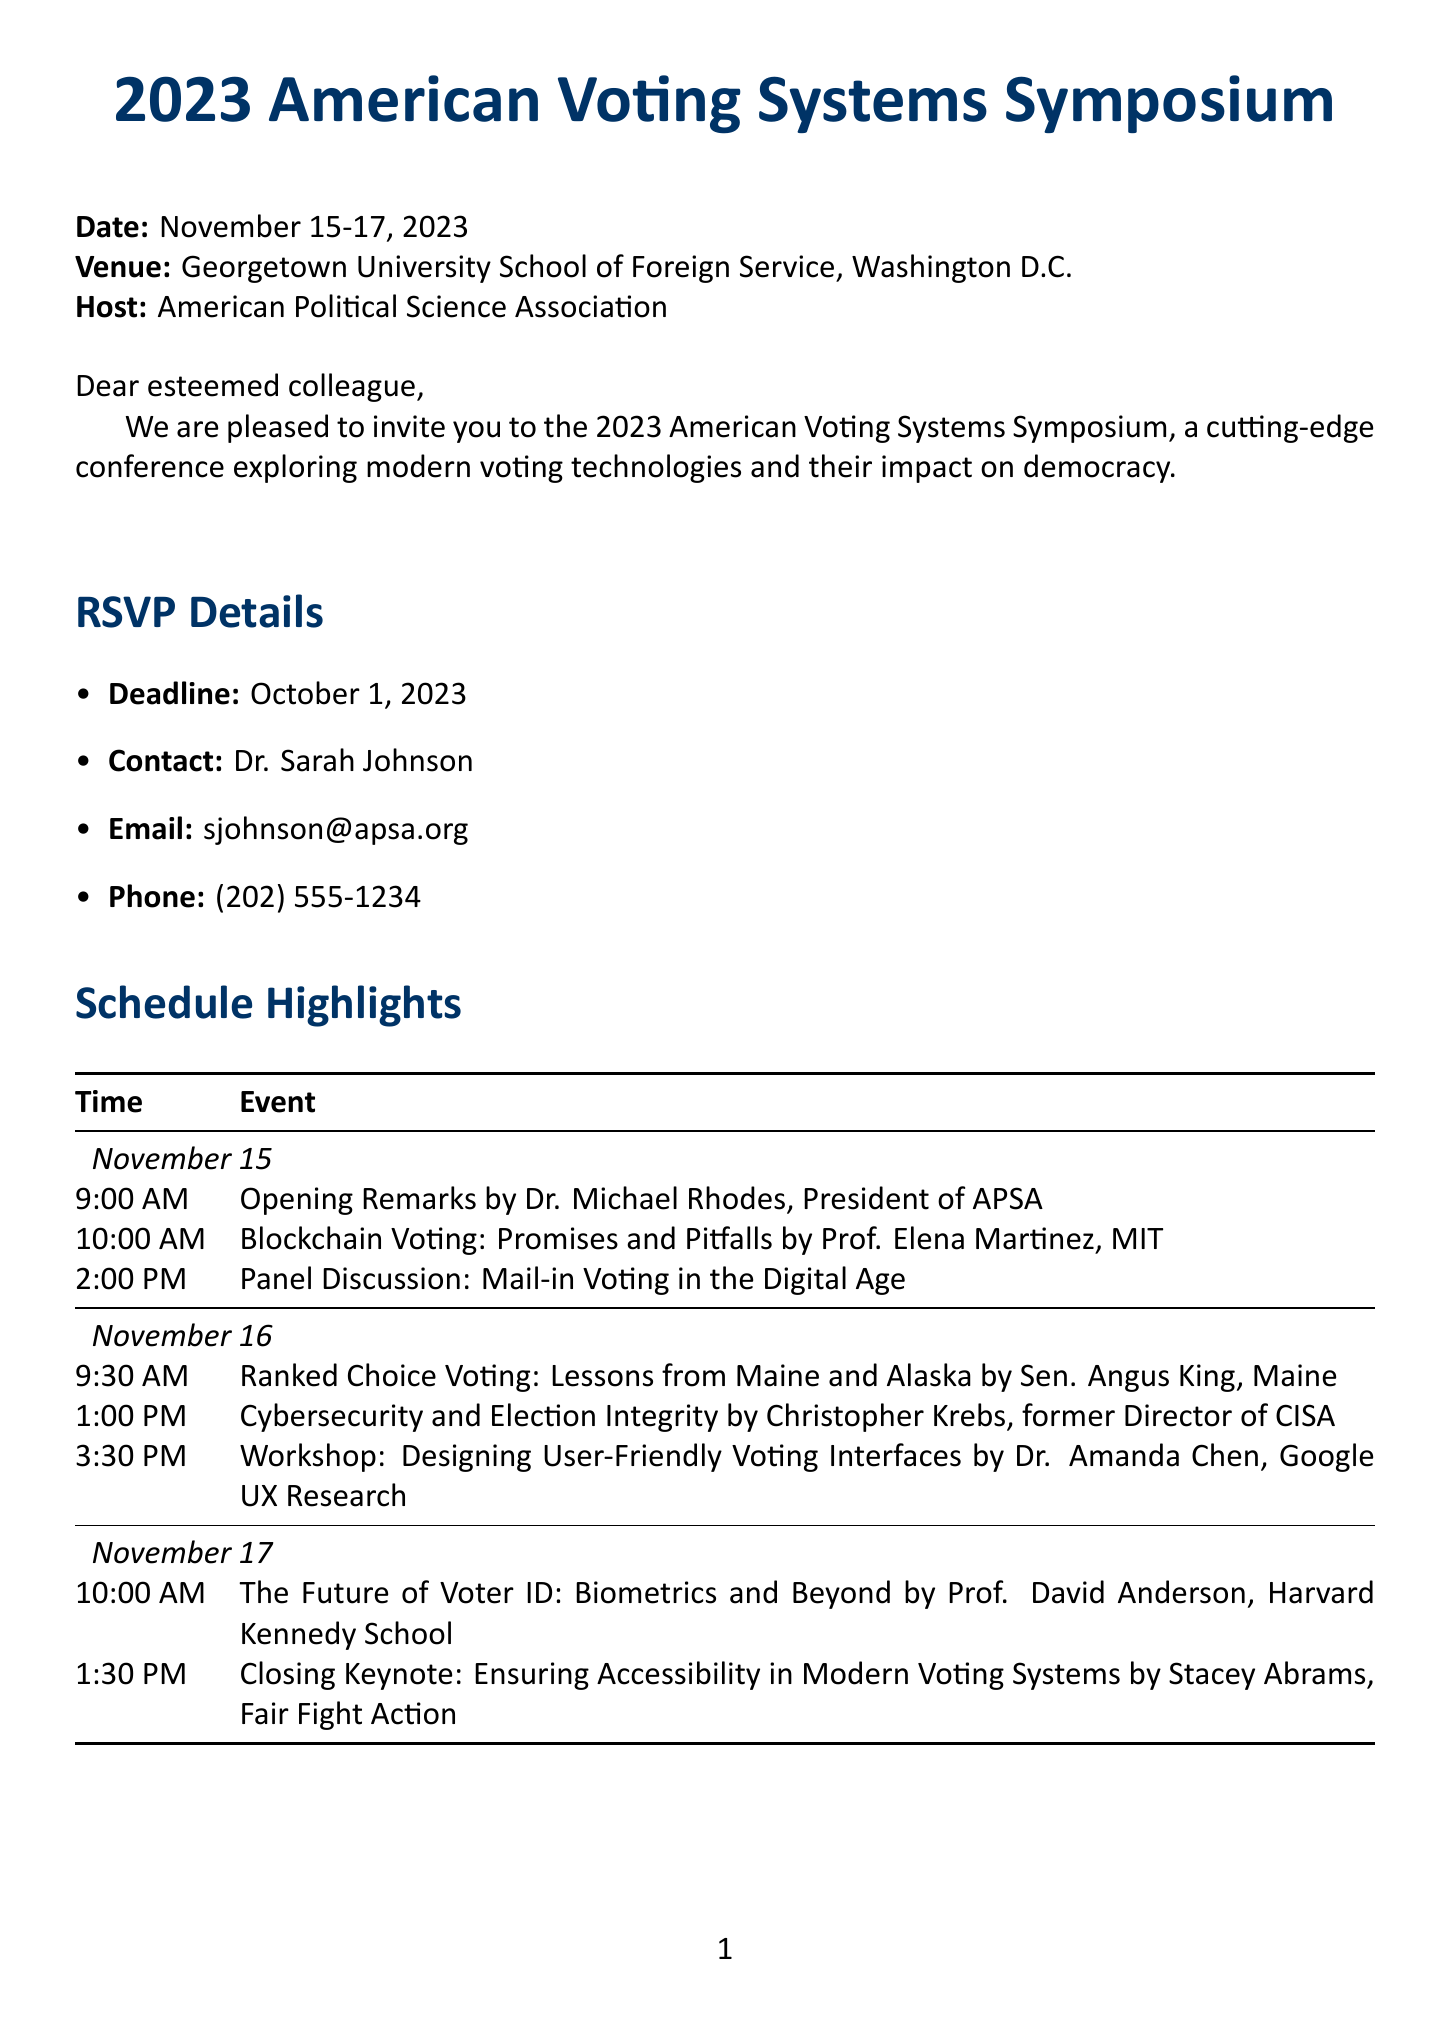What are the dates of the symposium? The dates of the symposium are clearly stated in the document, which lists them as November 15-17, 2023.
Answer: November 15-17, 2023 Who is the keynote speaker on November 17? The document specifies the closing keynote speaker on November 17 as Stacey Abrams, from Fair Fight Action.
Answer: Stacey Abrams What is the registration fee for students? The document lists the registration fee for students as $75.
Answer: $75 What hotel is recommended for attendees? The recommended hotel for attendees is directly mentioned in the accommodations section of the document.
Answer: Georgetown University Hotel and Conference Center What is the deadline for RSVP? The RSVP deadline is outlined in the document, which clearly states October 1, 2023, as the cut-off date.
Answer: October 1, 2023 Which speaker discusses cybersecurity? The schedule highlights Christopher Krebs as the speaker discussing cybersecurity and election integrity, as mentioned in the document.
Answer: Christopher Krebs How much is the early bird discount? The early bird discount is mentioned as a percentage off the regular price if registered by a specific date, which is 20 percent off.
Answer: 20% off What is the address of the recommended hotel? The document provides the full address of the recommended hotel, stated as 3800 Reservoir Rd NW, Washington, DC 20057.
Answer: 3800 Reservoir Rd NW, Washington, DC 20057 